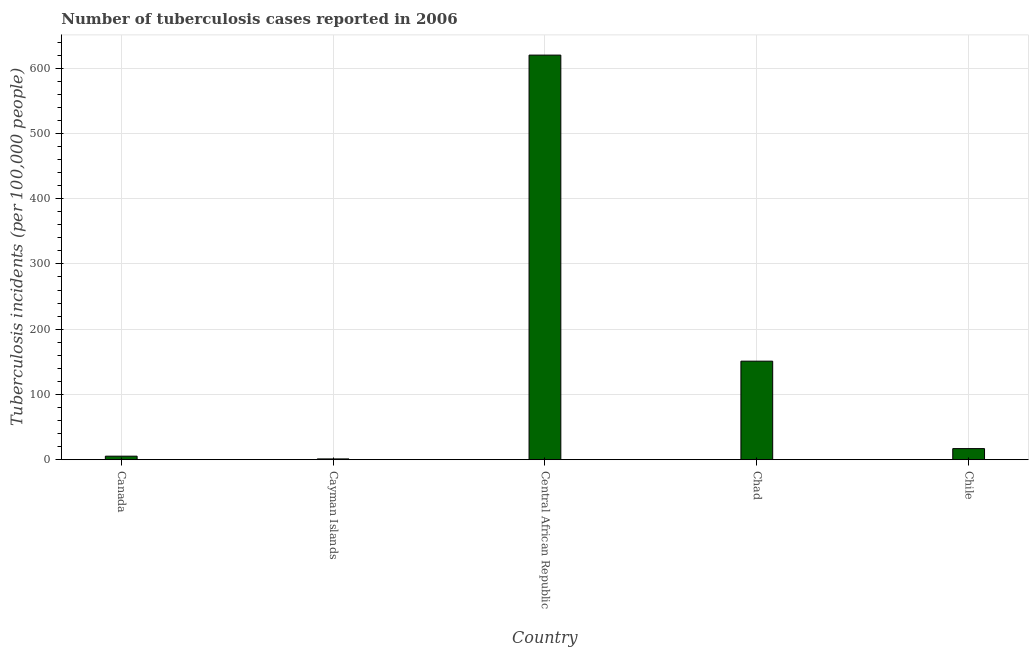Does the graph contain any zero values?
Keep it short and to the point. No. What is the title of the graph?
Make the answer very short. Number of tuberculosis cases reported in 2006. What is the label or title of the Y-axis?
Offer a terse response. Tuberculosis incidents (per 100,0 people). Across all countries, what is the maximum number of tuberculosis incidents?
Ensure brevity in your answer.  620. Across all countries, what is the minimum number of tuberculosis incidents?
Your answer should be very brief. 1.2. In which country was the number of tuberculosis incidents maximum?
Make the answer very short. Central African Republic. In which country was the number of tuberculosis incidents minimum?
Provide a short and direct response. Cayman Islands. What is the sum of the number of tuberculosis incidents?
Give a very brief answer. 794.6. What is the average number of tuberculosis incidents per country?
Offer a terse response. 158.92. What is the median number of tuberculosis incidents?
Offer a terse response. 17. What is the ratio of the number of tuberculosis incidents in Cayman Islands to that in Central African Republic?
Provide a succinct answer. 0. Is the number of tuberculosis incidents in Canada less than that in Chad?
Your response must be concise. Yes. Is the difference between the number of tuberculosis incidents in Cayman Islands and Chile greater than the difference between any two countries?
Give a very brief answer. No. What is the difference between the highest and the second highest number of tuberculosis incidents?
Provide a short and direct response. 469. Is the sum of the number of tuberculosis incidents in Cayman Islands and Central African Republic greater than the maximum number of tuberculosis incidents across all countries?
Your answer should be very brief. Yes. What is the difference between the highest and the lowest number of tuberculosis incidents?
Provide a short and direct response. 618.8. Are all the bars in the graph horizontal?
Provide a succinct answer. No. How many countries are there in the graph?
Provide a short and direct response. 5. Are the values on the major ticks of Y-axis written in scientific E-notation?
Ensure brevity in your answer.  No. What is the Tuberculosis incidents (per 100,000 people) of Cayman Islands?
Your response must be concise. 1.2. What is the Tuberculosis incidents (per 100,000 people) in Central African Republic?
Your answer should be compact. 620. What is the Tuberculosis incidents (per 100,000 people) of Chad?
Your answer should be very brief. 151. What is the Tuberculosis incidents (per 100,000 people) in Chile?
Ensure brevity in your answer.  17. What is the difference between the Tuberculosis incidents (per 100,000 people) in Canada and Cayman Islands?
Make the answer very short. 4.2. What is the difference between the Tuberculosis incidents (per 100,000 people) in Canada and Central African Republic?
Offer a very short reply. -614.6. What is the difference between the Tuberculosis incidents (per 100,000 people) in Canada and Chad?
Make the answer very short. -145.6. What is the difference between the Tuberculosis incidents (per 100,000 people) in Canada and Chile?
Offer a very short reply. -11.6. What is the difference between the Tuberculosis incidents (per 100,000 people) in Cayman Islands and Central African Republic?
Your answer should be very brief. -618.8. What is the difference between the Tuberculosis incidents (per 100,000 people) in Cayman Islands and Chad?
Keep it short and to the point. -149.8. What is the difference between the Tuberculosis incidents (per 100,000 people) in Cayman Islands and Chile?
Offer a very short reply. -15.8. What is the difference between the Tuberculosis incidents (per 100,000 people) in Central African Republic and Chad?
Give a very brief answer. 469. What is the difference between the Tuberculosis incidents (per 100,000 people) in Central African Republic and Chile?
Ensure brevity in your answer.  603. What is the difference between the Tuberculosis incidents (per 100,000 people) in Chad and Chile?
Give a very brief answer. 134. What is the ratio of the Tuberculosis incidents (per 100,000 people) in Canada to that in Central African Republic?
Give a very brief answer. 0.01. What is the ratio of the Tuberculosis incidents (per 100,000 people) in Canada to that in Chad?
Provide a short and direct response. 0.04. What is the ratio of the Tuberculosis incidents (per 100,000 people) in Canada to that in Chile?
Keep it short and to the point. 0.32. What is the ratio of the Tuberculosis incidents (per 100,000 people) in Cayman Islands to that in Central African Republic?
Offer a terse response. 0. What is the ratio of the Tuberculosis incidents (per 100,000 people) in Cayman Islands to that in Chad?
Offer a very short reply. 0.01. What is the ratio of the Tuberculosis incidents (per 100,000 people) in Cayman Islands to that in Chile?
Make the answer very short. 0.07. What is the ratio of the Tuberculosis incidents (per 100,000 people) in Central African Republic to that in Chad?
Offer a very short reply. 4.11. What is the ratio of the Tuberculosis incidents (per 100,000 people) in Central African Republic to that in Chile?
Provide a succinct answer. 36.47. What is the ratio of the Tuberculosis incidents (per 100,000 people) in Chad to that in Chile?
Offer a terse response. 8.88. 